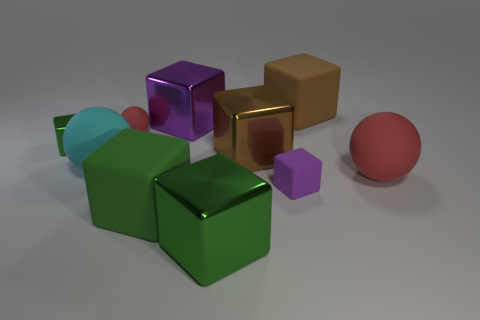Subtract all brown balls. How many green blocks are left? 3 Subtract all green blocks. How many blocks are left? 4 Subtract all green cubes. How many cubes are left? 4 Subtract all red cubes. Subtract all red spheres. How many cubes are left? 7 Subtract all cubes. How many objects are left? 3 Add 3 green rubber objects. How many green rubber objects are left? 4 Add 6 tiny purple rubber objects. How many tiny purple rubber objects exist? 7 Subtract 0 green spheres. How many objects are left? 10 Subtract all tiny red things. Subtract all big blue metal things. How many objects are left? 9 